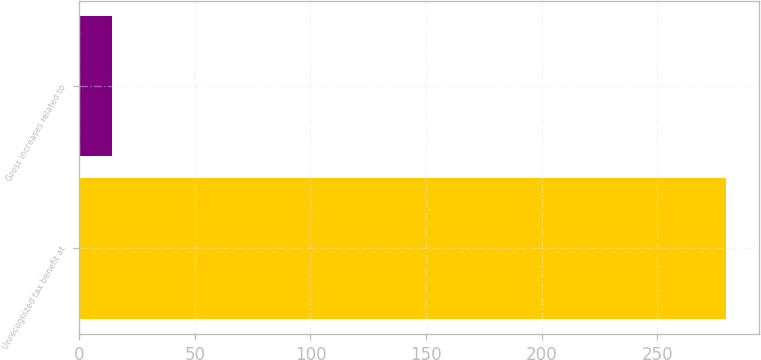<chart> <loc_0><loc_0><loc_500><loc_500><bar_chart><fcel>Unrecognized tax benefit at<fcel>Gross increases related to<nl><fcel>280<fcel>14<nl></chart> 